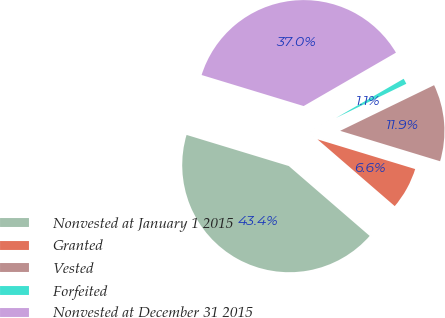Convert chart to OTSL. <chart><loc_0><loc_0><loc_500><loc_500><pie_chart><fcel>Nonvested at January 1 2015<fcel>Granted<fcel>Vested<fcel>Forfeited<fcel>Nonvested at December 31 2015<nl><fcel>43.36%<fcel>6.64%<fcel>11.9%<fcel>1.15%<fcel>36.95%<nl></chart> 